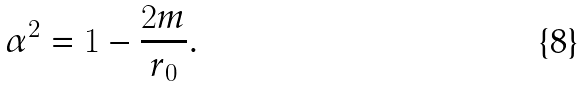<formula> <loc_0><loc_0><loc_500><loc_500>\alpha ^ { 2 } = 1 - \frac { 2 m } { r _ { 0 } } .</formula> 